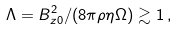<formula> <loc_0><loc_0><loc_500><loc_500>\Lambda = B _ { z 0 } ^ { 2 } / ( 8 \pi \rho \eta \Omega ) \gtrsim 1 \, ,</formula> 